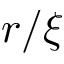Convert formula to latex. <formula><loc_0><loc_0><loc_500><loc_500>r / \xi</formula> 